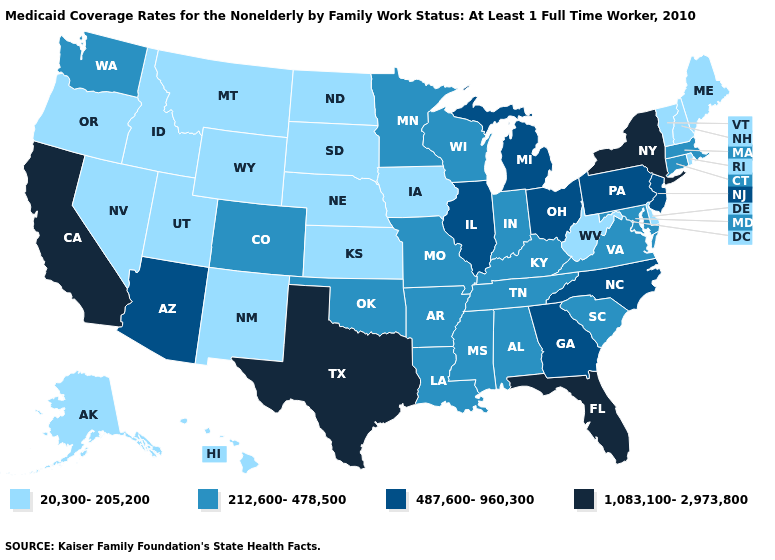What is the value of Rhode Island?
Be succinct. 20,300-205,200. Name the states that have a value in the range 1,083,100-2,973,800?
Give a very brief answer. California, Florida, New York, Texas. What is the lowest value in the USA?
Answer briefly. 20,300-205,200. How many symbols are there in the legend?
Answer briefly. 4. What is the value of Oklahoma?
Answer briefly. 212,600-478,500. Does Delaware have the lowest value in the South?
Answer briefly. Yes. Which states have the highest value in the USA?
Quick response, please. California, Florida, New York, Texas. What is the lowest value in the USA?
Quick response, please. 20,300-205,200. Does Illinois have the highest value in the MidWest?
Short answer required. Yes. What is the lowest value in the USA?
Concise answer only. 20,300-205,200. What is the highest value in the USA?
Concise answer only. 1,083,100-2,973,800. Name the states that have a value in the range 487,600-960,300?
Give a very brief answer. Arizona, Georgia, Illinois, Michigan, New Jersey, North Carolina, Ohio, Pennsylvania. Does the map have missing data?
Be succinct. No. What is the value of Illinois?
Be succinct. 487,600-960,300. Which states have the lowest value in the West?
Short answer required. Alaska, Hawaii, Idaho, Montana, Nevada, New Mexico, Oregon, Utah, Wyoming. 